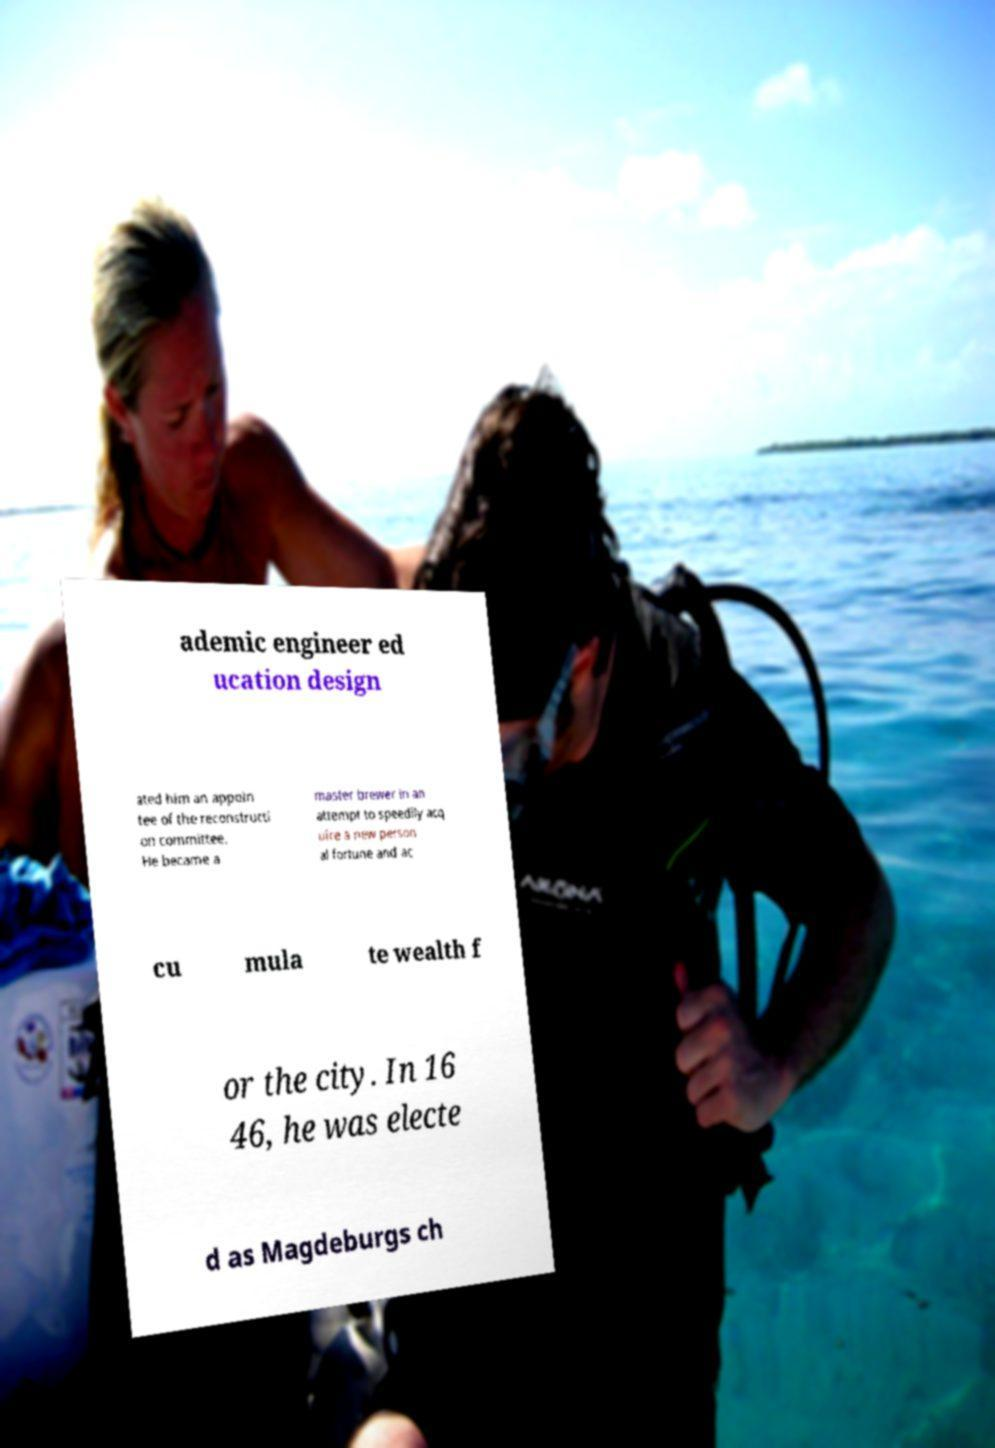I need the written content from this picture converted into text. Can you do that? ademic engineer ed ucation design ated him an appoin tee of the reconstructi on committee. He became a master brewer in an attempt to speedily acq uire a new person al fortune and ac cu mula te wealth f or the city. In 16 46, he was electe d as Magdeburgs ch 